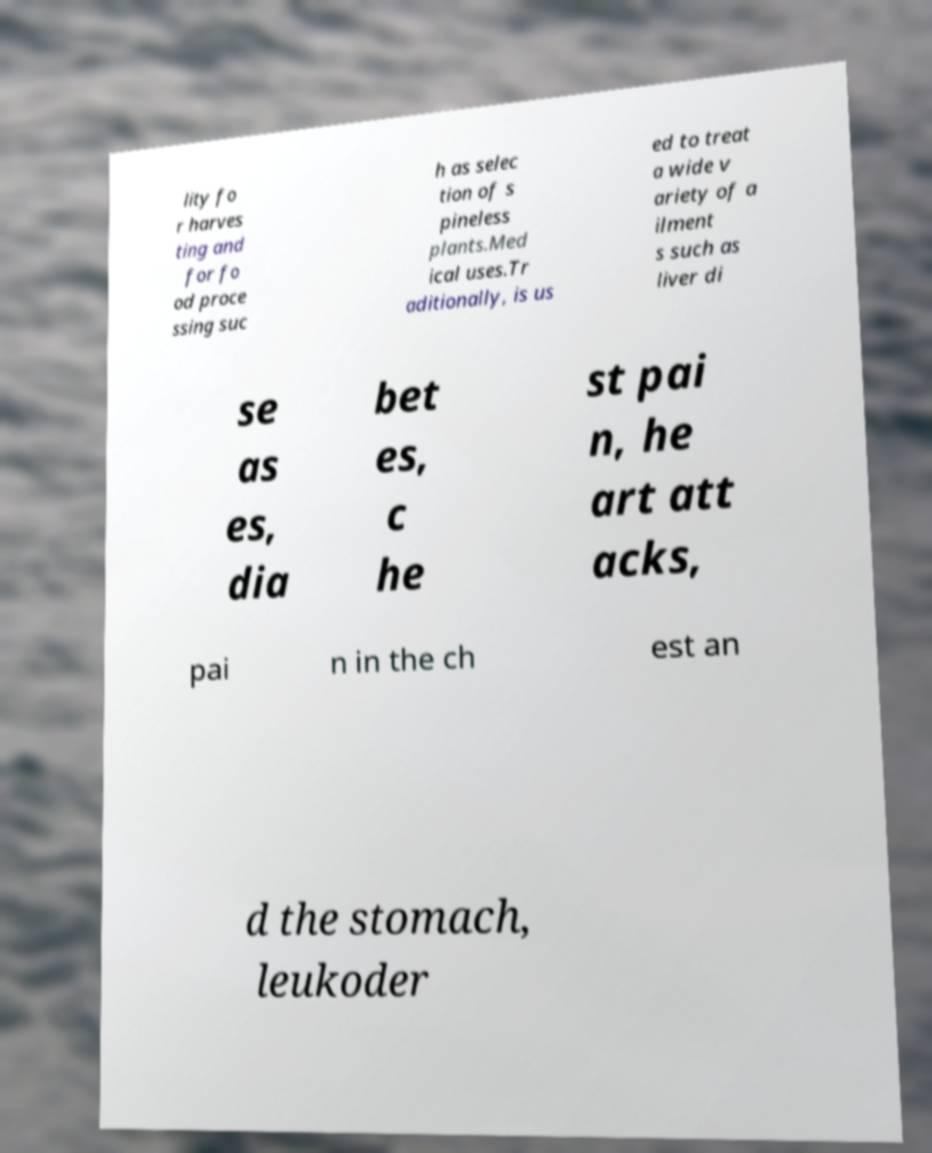Please read and relay the text visible in this image. What does it say? lity fo r harves ting and for fo od proce ssing suc h as selec tion of s pineless plants.Med ical uses.Tr aditionally, is us ed to treat a wide v ariety of a ilment s such as liver di se as es, dia bet es, c he st pai n, he art att acks, pai n in the ch est an d the stomach, leukoder 